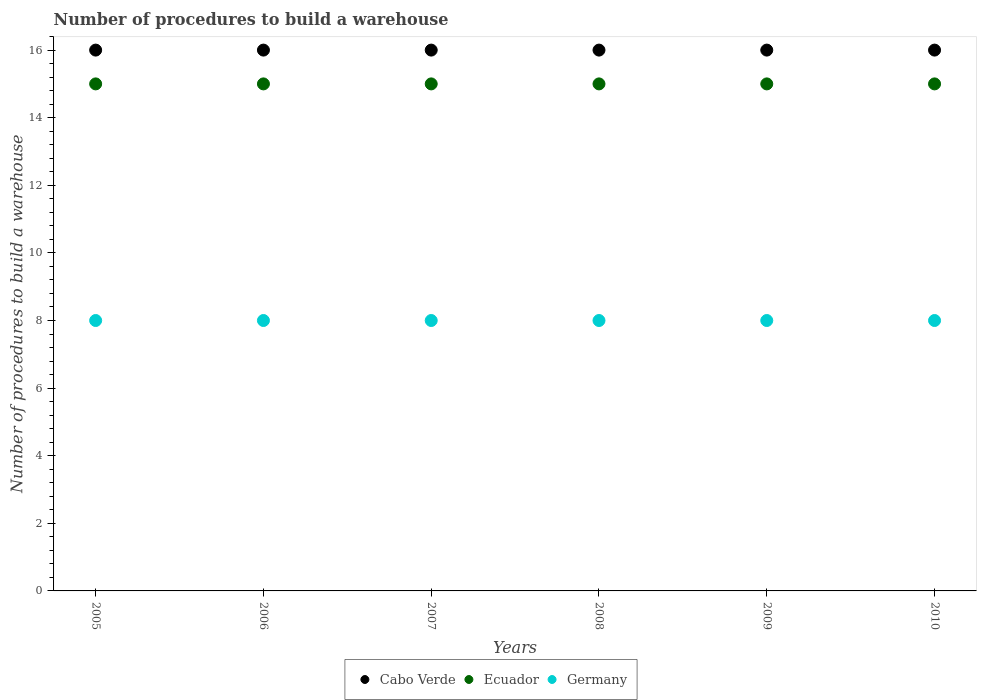How many different coloured dotlines are there?
Provide a succinct answer. 3. Is the number of dotlines equal to the number of legend labels?
Your answer should be very brief. Yes. What is the number of procedures to build a warehouse in in Cabo Verde in 2006?
Offer a very short reply. 16. Across all years, what is the maximum number of procedures to build a warehouse in in Cabo Verde?
Provide a short and direct response. 16. Across all years, what is the minimum number of procedures to build a warehouse in in Germany?
Provide a succinct answer. 8. In which year was the number of procedures to build a warehouse in in Ecuador maximum?
Offer a very short reply. 2005. What is the total number of procedures to build a warehouse in in Cabo Verde in the graph?
Make the answer very short. 96. What is the difference between the number of procedures to build a warehouse in in Germany in 2006 and the number of procedures to build a warehouse in in Cabo Verde in 2010?
Offer a terse response. -8. In the year 2007, what is the difference between the number of procedures to build a warehouse in in Ecuador and number of procedures to build a warehouse in in Cabo Verde?
Your answer should be compact. -1. What is the ratio of the number of procedures to build a warehouse in in Cabo Verde in 2006 to that in 2007?
Give a very brief answer. 1. What is the difference between the highest and the lowest number of procedures to build a warehouse in in Ecuador?
Make the answer very short. 0. Is the sum of the number of procedures to build a warehouse in in Ecuador in 2009 and 2010 greater than the maximum number of procedures to build a warehouse in in Germany across all years?
Your answer should be compact. Yes. How many years are there in the graph?
Offer a very short reply. 6. Are the values on the major ticks of Y-axis written in scientific E-notation?
Provide a succinct answer. No. Does the graph contain grids?
Your response must be concise. No. What is the title of the graph?
Your response must be concise. Number of procedures to build a warehouse. Does "United Arab Emirates" appear as one of the legend labels in the graph?
Provide a succinct answer. No. What is the label or title of the X-axis?
Your answer should be very brief. Years. What is the label or title of the Y-axis?
Offer a very short reply. Number of procedures to build a warehouse. What is the Number of procedures to build a warehouse in Cabo Verde in 2005?
Offer a very short reply. 16. What is the Number of procedures to build a warehouse in Ecuador in 2005?
Your answer should be compact. 15. What is the Number of procedures to build a warehouse of Germany in 2005?
Provide a succinct answer. 8. What is the Number of procedures to build a warehouse of Cabo Verde in 2006?
Provide a short and direct response. 16. What is the Number of procedures to build a warehouse of Ecuador in 2006?
Make the answer very short. 15. What is the Number of procedures to build a warehouse in Germany in 2007?
Make the answer very short. 8. What is the Number of procedures to build a warehouse of Cabo Verde in 2008?
Keep it short and to the point. 16. What is the Number of procedures to build a warehouse of Germany in 2008?
Provide a short and direct response. 8. What is the Number of procedures to build a warehouse of Germany in 2009?
Your answer should be very brief. 8. Across all years, what is the maximum Number of procedures to build a warehouse in Cabo Verde?
Offer a very short reply. 16. Across all years, what is the maximum Number of procedures to build a warehouse of Ecuador?
Your response must be concise. 15. Across all years, what is the minimum Number of procedures to build a warehouse of Cabo Verde?
Your answer should be very brief. 16. Across all years, what is the minimum Number of procedures to build a warehouse of Germany?
Your answer should be very brief. 8. What is the total Number of procedures to build a warehouse of Cabo Verde in the graph?
Ensure brevity in your answer.  96. What is the total Number of procedures to build a warehouse of Ecuador in the graph?
Your answer should be compact. 90. What is the total Number of procedures to build a warehouse of Germany in the graph?
Offer a terse response. 48. What is the difference between the Number of procedures to build a warehouse in Cabo Verde in 2005 and that in 2006?
Make the answer very short. 0. What is the difference between the Number of procedures to build a warehouse in Ecuador in 2005 and that in 2007?
Your answer should be very brief. 0. What is the difference between the Number of procedures to build a warehouse of Germany in 2005 and that in 2007?
Provide a short and direct response. 0. What is the difference between the Number of procedures to build a warehouse in Germany in 2005 and that in 2008?
Offer a very short reply. 0. What is the difference between the Number of procedures to build a warehouse of Ecuador in 2005 and that in 2010?
Offer a terse response. 0. What is the difference between the Number of procedures to build a warehouse in Germany in 2005 and that in 2010?
Make the answer very short. 0. What is the difference between the Number of procedures to build a warehouse in Cabo Verde in 2006 and that in 2007?
Provide a succinct answer. 0. What is the difference between the Number of procedures to build a warehouse of Ecuador in 2006 and that in 2007?
Provide a short and direct response. 0. What is the difference between the Number of procedures to build a warehouse of Cabo Verde in 2006 and that in 2008?
Keep it short and to the point. 0. What is the difference between the Number of procedures to build a warehouse of Ecuador in 2006 and that in 2008?
Your response must be concise. 0. What is the difference between the Number of procedures to build a warehouse in Germany in 2006 and that in 2008?
Give a very brief answer. 0. What is the difference between the Number of procedures to build a warehouse of Ecuador in 2006 and that in 2009?
Ensure brevity in your answer.  0. What is the difference between the Number of procedures to build a warehouse in Cabo Verde in 2006 and that in 2010?
Your response must be concise. 0. What is the difference between the Number of procedures to build a warehouse of Cabo Verde in 2007 and that in 2008?
Provide a succinct answer. 0. What is the difference between the Number of procedures to build a warehouse in Ecuador in 2007 and that in 2008?
Your response must be concise. 0. What is the difference between the Number of procedures to build a warehouse in Germany in 2007 and that in 2008?
Give a very brief answer. 0. What is the difference between the Number of procedures to build a warehouse of Cabo Verde in 2007 and that in 2009?
Keep it short and to the point. 0. What is the difference between the Number of procedures to build a warehouse in Germany in 2007 and that in 2010?
Keep it short and to the point. 0. What is the difference between the Number of procedures to build a warehouse of Cabo Verde in 2008 and that in 2009?
Provide a succinct answer. 0. What is the difference between the Number of procedures to build a warehouse in Ecuador in 2008 and that in 2009?
Your answer should be very brief. 0. What is the difference between the Number of procedures to build a warehouse of Germany in 2008 and that in 2009?
Make the answer very short. 0. What is the difference between the Number of procedures to build a warehouse in Cabo Verde in 2008 and that in 2010?
Your answer should be very brief. 0. What is the difference between the Number of procedures to build a warehouse of Germany in 2008 and that in 2010?
Provide a short and direct response. 0. What is the difference between the Number of procedures to build a warehouse of Cabo Verde in 2009 and that in 2010?
Give a very brief answer. 0. What is the difference between the Number of procedures to build a warehouse of Ecuador in 2009 and that in 2010?
Make the answer very short. 0. What is the difference between the Number of procedures to build a warehouse in Cabo Verde in 2005 and the Number of procedures to build a warehouse in Ecuador in 2007?
Offer a very short reply. 1. What is the difference between the Number of procedures to build a warehouse of Cabo Verde in 2005 and the Number of procedures to build a warehouse of Ecuador in 2008?
Give a very brief answer. 1. What is the difference between the Number of procedures to build a warehouse in Cabo Verde in 2005 and the Number of procedures to build a warehouse in Ecuador in 2009?
Ensure brevity in your answer.  1. What is the difference between the Number of procedures to build a warehouse of Cabo Verde in 2005 and the Number of procedures to build a warehouse of Germany in 2009?
Ensure brevity in your answer.  8. What is the difference between the Number of procedures to build a warehouse of Cabo Verde in 2005 and the Number of procedures to build a warehouse of Ecuador in 2010?
Provide a short and direct response. 1. What is the difference between the Number of procedures to build a warehouse of Cabo Verde in 2005 and the Number of procedures to build a warehouse of Germany in 2010?
Your response must be concise. 8. What is the difference between the Number of procedures to build a warehouse in Cabo Verde in 2006 and the Number of procedures to build a warehouse in Ecuador in 2008?
Give a very brief answer. 1. What is the difference between the Number of procedures to build a warehouse of Ecuador in 2006 and the Number of procedures to build a warehouse of Germany in 2008?
Ensure brevity in your answer.  7. What is the difference between the Number of procedures to build a warehouse of Cabo Verde in 2006 and the Number of procedures to build a warehouse of Ecuador in 2009?
Your response must be concise. 1. What is the difference between the Number of procedures to build a warehouse of Cabo Verde in 2006 and the Number of procedures to build a warehouse of Germany in 2009?
Keep it short and to the point. 8. What is the difference between the Number of procedures to build a warehouse of Cabo Verde in 2006 and the Number of procedures to build a warehouse of Germany in 2010?
Offer a very short reply. 8. What is the difference between the Number of procedures to build a warehouse of Ecuador in 2006 and the Number of procedures to build a warehouse of Germany in 2010?
Ensure brevity in your answer.  7. What is the difference between the Number of procedures to build a warehouse of Cabo Verde in 2007 and the Number of procedures to build a warehouse of Ecuador in 2008?
Give a very brief answer. 1. What is the difference between the Number of procedures to build a warehouse of Cabo Verde in 2007 and the Number of procedures to build a warehouse of Germany in 2008?
Your response must be concise. 8. What is the difference between the Number of procedures to build a warehouse in Ecuador in 2007 and the Number of procedures to build a warehouse in Germany in 2008?
Offer a terse response. 7. What is the difference between the Number of procedures to build a warehouse in Cabo Verde in 2007 and the Number of procedures to build a warehouse in Ecuador in 2009?
Provide a succinct answer. 1. What is the difference between the Number of procedures to build a warehouse in Cabo Verde in 2008 and the Number of procedures to build a warehouse in Ecuador in 2009?
Ensure brevity in your answer.  1. What is the difference between the Number of procedures to build a warehouse of Cabo Verde in 2008 and the Number of procedures to build a warehouse of Ecuador in 2010?
Give a very brief answer. 1. What is the difference between the Number of procedures to build a warehouse of Cabo Verde in 2008 and the Number of procedures to build a warehouse of Germany in 2010?
Your response must be concise. 8. What is the difference between the Number of procedures to build a warehouse of Ecuador in 2009 and the Number of procedures to build a warehouse of Germany in 2010?
Provide a short and direct response. 7. What is the average Number of procedures to build a warehouse in Ecuador per year?
Your response must be concise. 15. What is the average Number of procedures to build a warehouse in Germany per year?
Your answer should be very brief. 8. In the year 2005, what is the difference between the Number of procedures to build a warehouse in Ecuador and Number of procedures to build a warehouse in Germany?
Give a very brief answer. 7. In the year 2007, what is the difference between the Number of procedures to build a warehouse of Cabo Verde and Number of procedures to build a warehouse of Ecuador?
Make the answer very short. 1. In the year 2007, what is the difference between the Number of procedures to build a warehouse in Ecuador and Number of procedures to build a warehouse in Germany?
Make the answer very short. 7. In the year 2008, what is the difference between the Number of procedures to build a warehouse of Cabo Verde and Number of procedures to build a warehouse of Ecuador?
Offer a terse response. 1. In the year 2008, what is the difference between the Number of procedures to build a warehouse in Cabo Verde and Number of procedures to build a warehouse in Germany?
Offer a very short reply. 8. In the year 2009, what is the difference between the Number of procedures to build a warehouse in Ecuador and Number of procedures to build a warehouse in Germany?
Ensure brevity in your answer.  7. In the year 2010, what is the difference between the Number of procedures to build a warehouse of Ecuador and Number of procedures to build a warehouse of Germany?
Provide a short and direct response. 7. What is the ratio of the Number of procedures to build a warehouse of Cabo Verde in 2005 to that in 2006?
Offer a very short reply. 1. What is the ratio of the Number of procedures to build a warehouse of Ecuador in 2005 to that in 2006?
Keep it short and to the point. 1. What is the ratio of the Number of procedures to build a warehouse of Germany in 2005 to that in 2008?
Offer a terse response. 1. What is the ratio of the Number of procedures to build a warehouse of Ecuador in 2005 to that in 2009?
Give a very brief answer. 1. What is the ratio of the Number of procedures to build a warehouse in Germany in 2005 to that in 2009?
Keep it short and to the point. 1. What is the ratio of the Number of procedures to build a warehouse in Ecuador in 2005 to that in 2010?
Your answer should be very brief. 1. What is the ratio of the Number of procedures to build a warehouse of Ecuador in 2006 to that in 2007?
Ensure brevity in your answer.  1. What is the ratio of the Number of procedures to build a warehouse of Ecuador in 2006 to that in 2009?
Ensure brevity in your answer.  1. What is the ratio of the Number of procedures to build a warehouse in Cabo Verde in 2006 to that in 2010?
Offer a terse response. 1. What is the ratio of the Number of procedures to build a warehouse of Germany in 2006 to that in 2010?
Offer a very short reply. 1. What is the ratio of the Number of procedures to build a warehouse in Cabo Verde in 2007 to that in 2008?
Your answer should be compact. 1. What is the ratio of the Number of procedures to build a warehouse in Cabo Verde in 2007 to that in 2009?
Make the answer very short. 1. What is the ratio of the Number of procedures to build a warehouse of Germany in 2007 to that in 2009?
Your response must be concise. 1. What is the ratio of the Number of procedures to build a warehouse of Cabo Verde in 2007 to that in 2010?
Keep it short and to the point. 1. What is the ratio of the Number of procedures to build a warehouse in Germany in 2007 to that in 2010?
Your answer should be very brief. 1. What is the ratio of the Number of procedures to build a warehouse of Cabo Verde in 2008 to that in 2009?
Offer a terse response. 1. What is the ratio of the Number of procedures to build a warehouse in Ecuador in 2008 to that in 2009?
Provide a short and direct response. 1. What is the ratio of the Number of procedures to build a warehouse of Germany in 2008 to that in 2009?
Make the answer very short. 1. What is the ratio of the Number of procedures to build a warehouse in Germany in 2008 to that in 2010?
Keep it short and to the point. 1. What is the ratio of the Number of procedures to build a warehouse in Cabo Verde in 2009 to that in 2010?
Make the answer very short. 1. What is the ratio of the Number of procedures to build a warehouse of Germany in 2009 to that in 2010?
Keep it short and to the point. 1. What is the difference between the highest and the second highest Number of procedures to build a warehouse of Cabo Verde?
Offer a very short reply. 0. What is the difference between the highest and the second highest Number of procedures to build a warehouse in Germany?
Make the answer very short. 0. What is the difference between the highest and the lowest Number of procedures to build a warehouse of Ecuador?
Offer a very short reply. 0. What is the difference between the highest and the lowest Number of procedures to build a warehouse in Germany?
Ensure brevity in your answer.  0. 